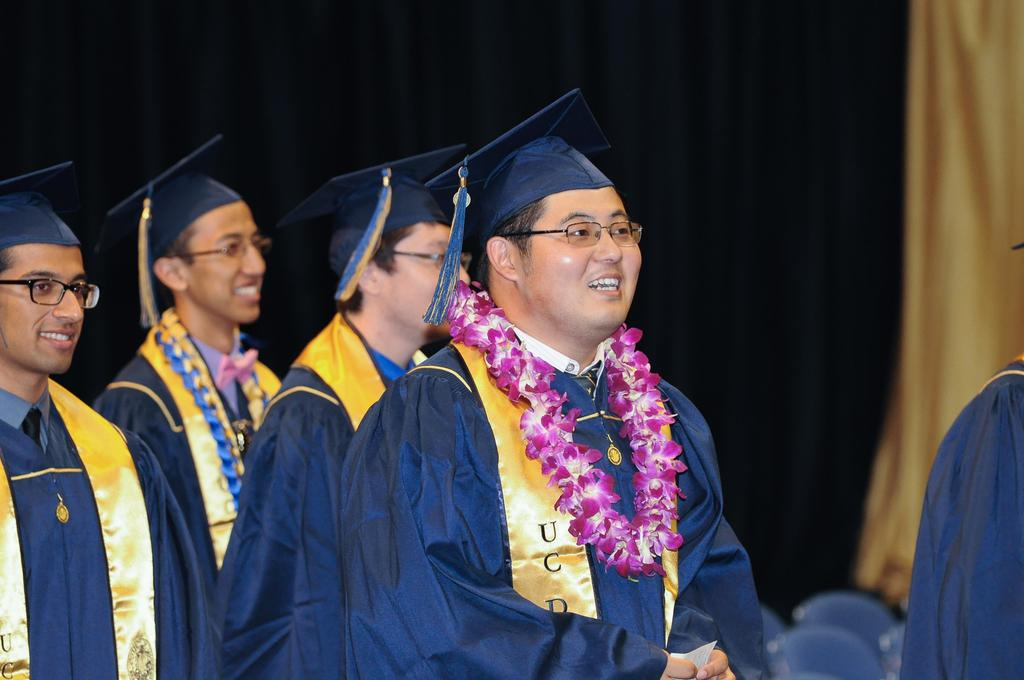How many people are in the image? There is a group of people in the image. Can you describe the person wearing a garland? One person is wearing a garland in the image. What is the person with the garland holding? The person with the garland is holding a paper. What can be seen in the background of the image? There are curtains visible in the background. What type of game is being played in the town depicted in the image? There is no town or game depicted in the image; it features a group of people, one of whom is wearing a garland and holding a paper. 